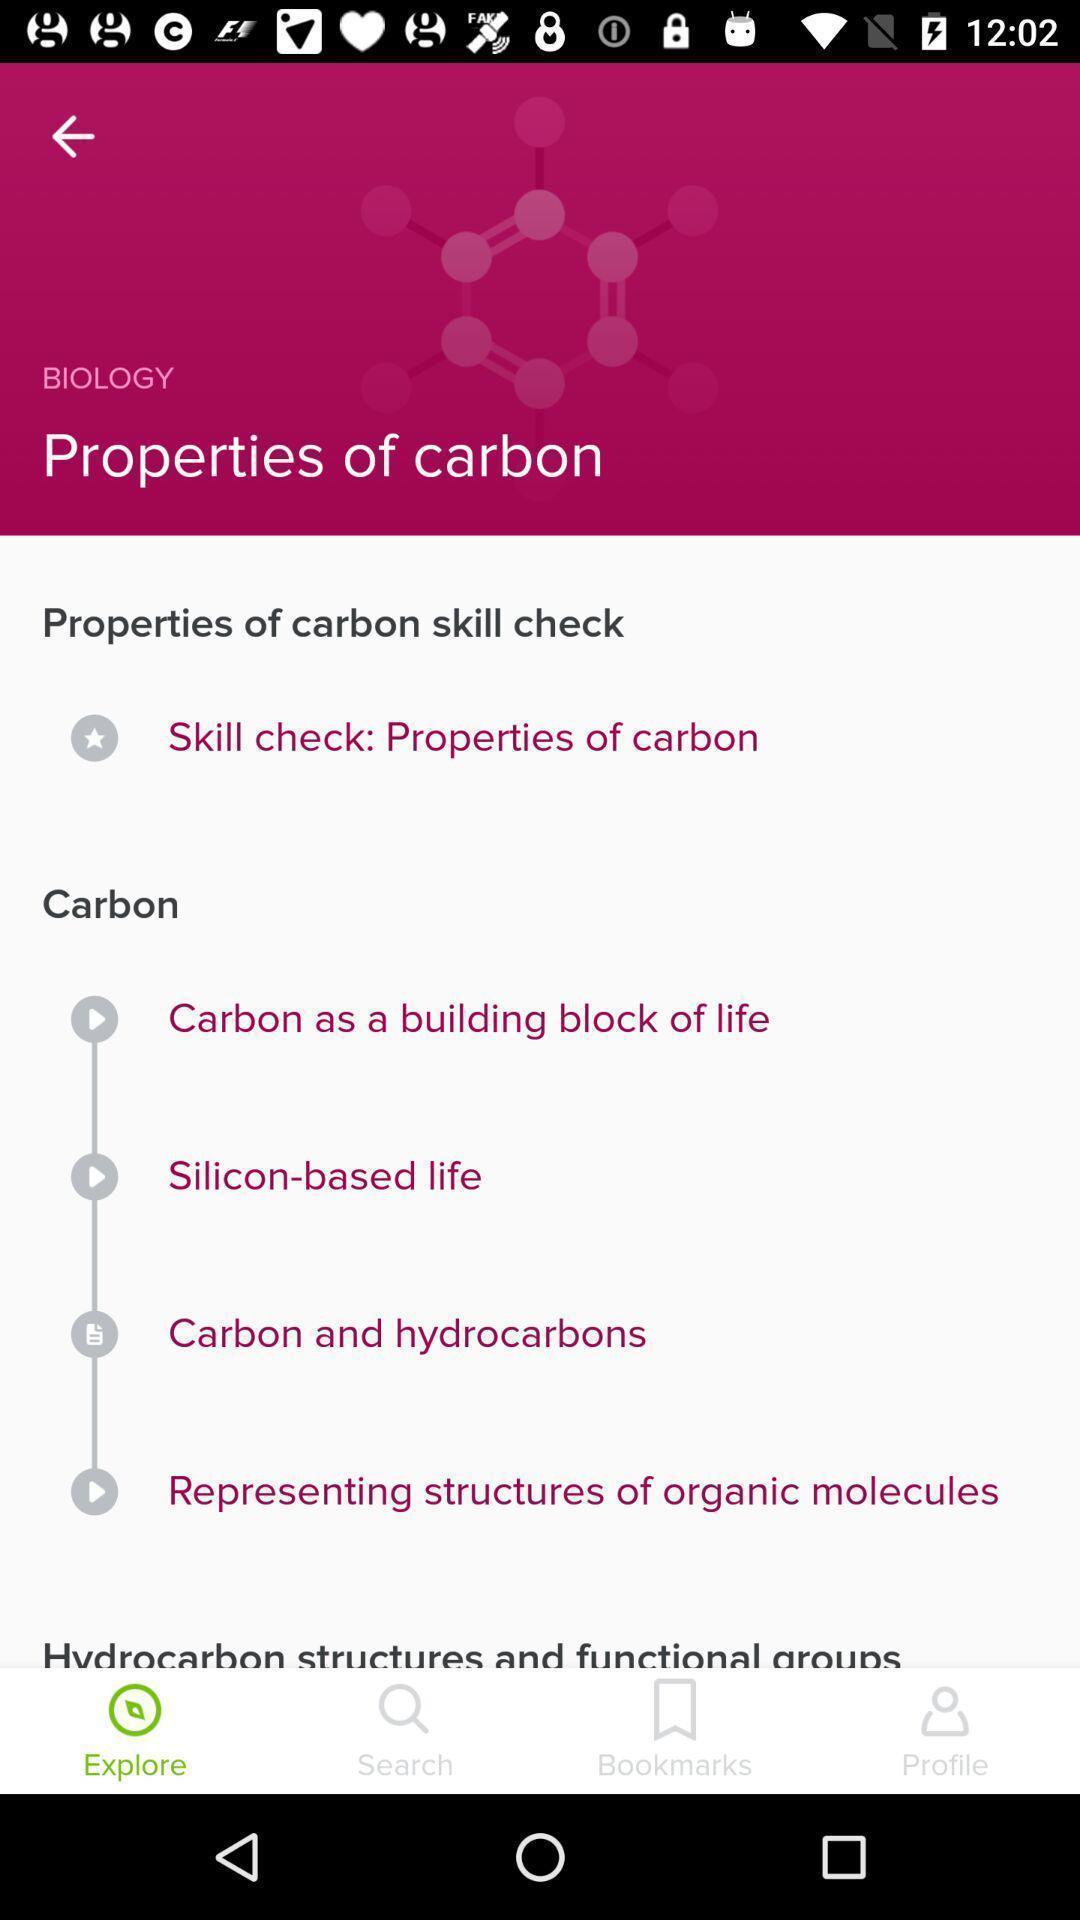Explain the elements present in this screenshot. Page shows information about a topic in the learning app. 